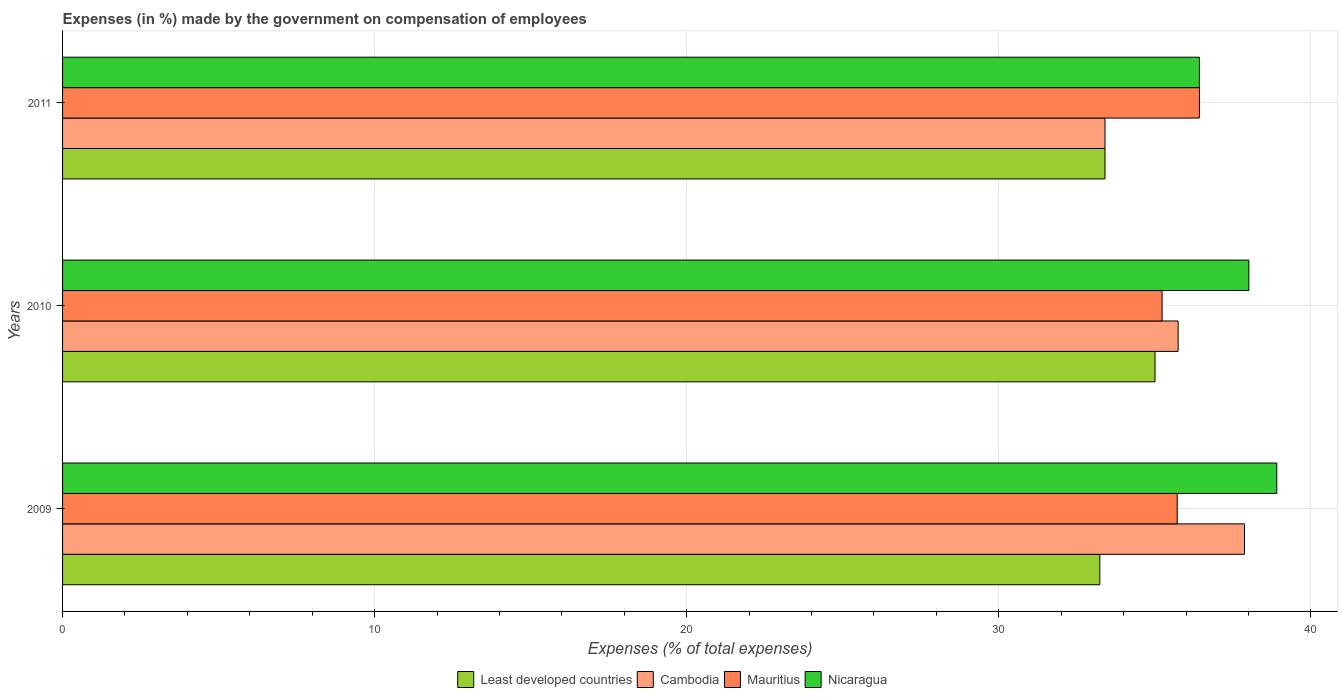How many groups of bars are there?
Your answer should be very brief. 3. How many bars are there on the 1st tick from the bottom?
Keep it short and to the point. 4. What is the label of the 3rd group of bars from the top?
Provide a short and direct response. 2009. What is the percentage of expenses made by the government on compensation of employees in Mauritius in 2011?
Provide a succinct answer. 36.43. Across all years, what is the maximum percentage of expenses made by the government on compensation of employees in Cambodia?
Keep it short and to the point. 37.88. Across all years, what is the minimum percentage of expenses made by the government on compensation of employees in Nicaragua?
Provide a succinct answer. 36.43. In which year was the percentage of expenses made by the government on compensation of employees in Least developed countries maximum?
Your answer should be compact. 2010. What is the total percentage of expenses made by the government on compensation of employees in Cambodia in the graph?
Offer a terse response. 107.03. What is the difference between the percentage of expenses made by the government on compensation of employees in Mauritius in 2009 and that in 2010?
Offer a very short reply. 0.49. What is the difference between the percentage of expenses made by the government on compensation of employees in Cambodia in 2010 and the percentage of expenses made by the government on compensation of employees in Least developed countries in 2009?
Your answer should be very brief. 2.51. What is the average percentage of expenses made by the government on compensation of employees in Nicaragua per year?
Offer a very short reply. 37.78. In the year 2009, what is the difference between the percentage of expenses made by the government on compensation of employees in Least developed countries and percentage of expenses made by the government on compensation of employees in Mauritius?
Provide a short and direct response. -2.48. In how many years, is the percentage of expenses made by the government on compensation of employees in Least developed countries greater than 34 %?
Give a very brief answer. 1. What is the ratio of the percentage of expenses made by the government on compensation of employees in Mauritius in 2009 to that in 2010?
Make the answer very short. 1.01. Is the difference between the percentage of expenses made by the government on compensation of employees in Least developed countries in 2009 and 2011 greater than the difference between the percentage of expenses made by the government on compensation of employees in Mauritius in 2009 and 2011?
Your response must be concise. Yes. What is the difference between the highest and the second highest percentage of expenses made by the government on compensation of employees in Mauritius?
Your answer should be compact. 0.71. What is the difference between the highest and the lowest percentage of expenses made by the government on compensation of employees in Nicaragua?
Make the answer very short. 2.48. Is the sum of the percentage of expenses made by the government on compensation of employees in Nicaragua in 2010 and 2011 greater than the maximum percentage of expenses made by the government on compensation of employees in Mauritius across all years?
Keep it short and to the point. Yes. What does the 4th bar from the top in 2010 represents?
Offer a very short reply. Least developed countries. What does the 3rd bar from the bottom in 2010 represents?
Offer a terse response. Mauritius. Is it the case that in every year, the sum of the percentage of expenses made by the government on compensation of employees in Cambodia and percentage of expenses made by the government on compensation of employees in Nicaragua is greater than the percentage of expenses made by the government on compensation of employees in Mauritius?
Offer a terse response. Yes. How many years are there in the graph?
Keep it short and to the point. 3. Are the values on the major ticks of X-axis written in scientific E-notation?
Keep it short and to the point. No. Does the graph contain any zero values?
Your answer should be very brief. No. Does the graph contain grids?
Keep it short and to the point. Yes. How are the legend labels stacked?
Provide a succinct answer. Horizontal. What is the title of the graph?
Give a very brief answer. Expenses (in %) made by the government on compensation of employees. Does "Finland" appear as one of the legend labels in the graph?
Ensure brevity in your answer.  No. What is the label or title of the X-axis?
Provide a succinct answer. Expenses (% of total expenses). What is the label or title of the Y-axis?
Offer a terse response. Years. What is the Expenses (% of total expenses) in Least developed countries in 2009?
Your answer should be compact. 33.24. What is the Expenses (% of total expenses) of Cambodia in 2009?
Your answer should be very brief. 37.88. What is the Expenses (% of total expenses) of Mauritius in 2009?
Offer a terse response. 35.72. What is the Expenses (% of total expenses) in Nicaragua in 2009?
Provide a short and direct response. 38.91. What is the Expenses (% of total expenses) in Least developed countries in 2010?
Your answer should be very brief. 35.01. What is the Expenses (% of total expenses) of Cambodia in 2010?
Your answer should be very brief. 35.75. What is the Expenses (% of total expenses) of Mauritius in 2010?
Provide a short and direct response. 35.23. What is the Expenses (% of total expenses) in Nicaragua in 2010?
Provide a short and direct response. 38.01. What is the Expenses (% of total expenses) of Least developed countries in 2011?
Give a very brief answer. 33.4. What is the Expenses (% of total expenses) in Cambodia in 2011?
Make the answer very short. 33.4. What is the Expenses (% of total expenses) of Mauritius in 2011?
Keep it short and to the point. 36.43. What is the Expenses (% of total expenses) of Nicaragua in 2011?
Provide a short and direct response. 36.43. Across all years, what is the maximum Expenses (% of total expenses) in Least developed countries?
Make the answer very short. 35.01. Across all years, what is the maximum Expenses (% of total expenses) of Cambodia?
Give a very brief answer. 37.88. Across all years, what is the maximum Expenses (% of total expenses) in Mauritius?
Your answer should be compact. 36.43. Across all years, what is the maximum Expenses (% of total expenses) of Nicaragua?
Keep it short and to the point. 38.91. Across all years, what is the minimum Expenses (% of total expenses) in Least developed countries?
Give a very brief answer. 33.24. Across all years, what is the minimum Expenses (% of total expenses) in Cambodia?
Keep it short and to the point. 33.4. Across all years, what is the minimum Expenses (% of total expenses) of Mauritius?
Provide a short and direct response. 35.23. Across all years, what is the minimum Expenses (% of total expenses) of Nicaragua?
Offer a very short reply. 36.43. What is the total Expenses (% of total expenses) in Least developed countries in the graph?
Provide a succinct answer. 101.65. What is the total Expenses (% of total expenses) of Cambodia in the graph?
Your answer should be very brief. 107.03. What is the total Expenses (% of total expenses) in Mauritius in the graph?
Your response must be concise. 107.38. What is the total Expenses (% of total expenses) in Nicaragua in the graph?
Provide a short and direct response. 113.35. What is the difference between the Expenses (% of total expenses) in Least developed countries in 2009 and that in 2010?
Provide a short and direct response. -1.77. What is the difference between the Expenses (% of total expenses) of Cambodia in 2009 and that in 2010?
Offer a terse response. 2.13. What is the difference between the Expenses (% of total expenses) of Mauritius in 2009 and that in 2010?
Your answer should be very brief. 0.49. What is the difference between the Expenses (% of total expenses) of Nicaragua in 2009 and that in 2010?
Make the answer very short. 0.89. What is the difference between the Expenses (% of total expenses) in Least developed countries in 2009 and that in 2011?
Offer a very short reply. -0.17. What is the difference between the Expenses (% of total expenses) of Cambodia in 2009 and that in 2011?
Your answer should be very brief. 4.47. What is the difference between the Expenses (% of total expenses) in Mauritius in 2009 and that in 2011?
Offer a very short reply. -0.71. What is the difference between the Expenses (% of total expenses) in Nicaragua in 2009 and that in 2011?
Provide a short and direct response. 2.48. What is the difference between the Expenses (% of total expenses) of Least developed countries in 2010 and that in 2011?
Your answer should be compact. 1.6. What is the difference between the Expenses (% of total expenses) of Cambodia in 2010 and that in 2011?
Offer a very short reply. 2.34. What is the difference between the Expenses (% of total expenses) in Mauritius in 2010 and that in 2011?
Make the answer very short. -1.2. What is the difference between the Expenses (% of total expenses) of Nicaragua in 2010 and that in 2011?
Your answer should be compact. 1.58. What is the difference between the Expenses (% of total expenses) of Least developed countries in 2009 and the Expenses (% of total expenses) of Cambodia in 2010?
Your response must be concise. -2.51. What is the difference between the Expenses (% of total expenses) of Least developed countries in 2009 and the Expenses (% of total expenses) of Mauritius in 2010?
Offer a terse response. -1.99. What is the difference between the Expenses (% of total expenses) in Least developed countries in 2009 and the Expenses (% of total expenses) in Nicaragua in 2010?
Provide a succinct answer. -4.78. What is the difference between the Expenses (% of total expenses) of Cambodia in 2009 and the Expenses (% of total expenses) of Mauritius in 2010?
Provide a succinct answer. 2.64. What is the difference between the Expenses (% of total expenses) of Cambodia in 2009 and the Expenses (% of total expenses) of Nicaragua in 2010?
Your answer should be very brief. -0.14. What is the difference between the Expenses (% of total expenses) in Mauritius in 2009 and the Expenses (% of total expenses) in Nicaragua in 2010?
Ensure brevity in your answer.  -2.3. What is the difference between the Expenses (% of total expenses) of Least developed countries in 2009 and the Expenses (% of total expenses) of Cambodia in 2011?
Offer a terse response. -0.17. What is the difference between the Expenses (% of total expenses) of Least developed countries in 2009 and the Expenses (% of total expenses) of Mauritius in 2011?
Give a very brief answer. -3.19. What is the difference between the Expenses (% of total expenses) of Least developed countries in 2009 and the Expenses (% of total expenses) of Nicaragua in 2011?
Give a very brief answer. -3.19. What is the difference between the Expenses (% of total expenses) of Cambodia in 2009 and the Expenses (% of total expenses) of Mauritius in 2011?
Offer a very short reply. 1.45. What is the difference between the Expenses (% of total expenses) of Cambodia in 2009 and the Expenses (% of total expenses) of Nicaragua in 2011?
Provide a succinct answer. 1.45. What is the difference between the Expenses (% of total expenses) of Mauritius in 2009 and the Expenses (% of total expenses) of Nicaragua in 2011?
Keep it short and to the point. -0.71. What is the difference between the Expenses (% of total expenses) in Least developed countries in 2010 and the Expenses (% of total expenses) in Cambodia in 2011?
Your answer should be compact. 1.6. What is the difference between the Expenses (% of total expenses) of Least developed countries in 2010 and the Expenses (% of total expenses) of Mauritius in 2011?
Provide a succinct answer. -1.42. What is the difference between the Expenses (% of total expenses) in Least developed countries in 2010 and the Expenses (% of total expenses) in Nicaragua in 2011?
Make the answer very short. -1.42. What is the difference between the Expenses (% of total expenses) of Cambodia in 2010 and the Expenses (% of total expenses) of Mauritius in 2011?
Keep it short and to the point. -0.68. What is the difference between the Expenses (% of total expenses) in Cambodia in 2010 and the Expenses (% of total expenses) in Nicaragua in 2011?
Offer a terse response. -0.68. What is the difference between the Expenses (% of total expenses) of Mauritius in 2010 and the Expenses (% of total expenses) of Nicaragua in 2011?
Provide a short and direct response. -1.2. What is the average Expenses (% of total expenses) of Least developed countries per year?
Make the answer very short. 33.88. What is the average Expenses (% of total expenses) in Cambodia per year?
Provide a succinct answer. 35.68. What is the average Expenses (% of total expenses) in Mauritius per year?
Keep it short and to the point. 35.79. What is the average Expenses (% of total expenses) in Nicaragua per year?
Your answer should be compact. 37.78. In the year 2009, what is the difference between the Expenses (% of total expenses) in Least developed countries and Expenses (% of total expenses) in Cambodia?
Your answer should be compact. -4.64. In the year 2009, what is the difference between the Expenses (% of total expenses) in Least developed countries and Expenses (% of total expenses) in Mauritius?
Keep it short and to the point. -2.48. In the year 2009, what is the difference between the Expenses (% of total expenses) of Least developed countries and Expenses (% of total expenses) of Nicaragua?
Provide a succinct answer. -5.67. In the year 2009, what is the difference between the Expenses (% of total expenses) of Cambodia and Expenses (% of total expenses) of Mauritius?
Your answer should be compact. 2.16. In the year 2009, what is the difference between the Expenses (% of total expenses) of Cambodia and Expenses (% of total expenses) of Nicaragua?
Your answer should be compact. -1.03. In the year 2009, what is the difference between the Expenses (% of total expenses) in Mauritius and Expenses (% of total expenses) in Nicaragua?
Keep it short and to the point. -3.19. In the year 2010, what is the difference between the Expenses (% of total expenses) in Least developed countries and Expenses (% of total expenses) in Cambodia?
Ensure brevity in your answer.  -0.74. In the year 2010, what is the difference between the Expenses (% of total expenses) in Least developed countries and Expenses (% of total expenses) in Mauritius?
Offer a very short reply. -0.23. In the year 2010, what is the difference between the Expenses (% of total expenses) in Least developed countries and Expenses (% of total expenses) in Nicaragua?
Your response must be concise. -3.01. In the year 2010, what is the difference between the Expenses (% of total expenses) of Cambodia and Expenses (% of total expenses) of Mauritius?
Provide a short and direct response. 0.51. In the year 2010, what is the difference between the Expenses (% of total expenses) in Cambodia and Expenses (% of total expenses) in Nicaragua?
Keep it short and to the point. -2.27. In the year 2010, what is the difference between the Expenses (% of total expenses) in Mauritius and Expenses (% of total expenses) in Nicaragua?
Your response must be concise. -2.78. In the year 2011, what is the difference between the Expenses (% of total expenses) in Least developed countries and Expenses (% of total expenses) in Cambodia?
Provide a short and direct response. 0. In the year 2011, what is the difference between the Expenses (% of total expenses) in Least developed countries and Expenses (% of total expenses) in Mauritius?
Make the answer very short. -3.03. In the year 2011, what is the difference between the Expenses (% of total expenses) in Least developed countries and Expenses (% of total expenses) in Nicaragua?
Offer a terse response. -3.03. In the year 2011, what is the difference between the Expenses (% of total expenses) of Cambodia and Expenses (% of total expenses) of Mauritius?
Offer a very short reply. -3.03. In the year 2011, what is the difference between the Expenses (% of total expenses) in Cambodia and Expenses (% of total expenses) in Nicaragua?
Your answer should be very brief. -3.03. In the year 2011, what is the difference between the Expenses (% of total expenses) in Mauritius and Expenses (% of total expenses) in Nicaragua?
Your answer should be compact. -0. What is the ratio of the Expenses (% of total expenses) in Least developed countries in 2009 to that in 2010?
Provide a succinct answer. 0.95. What is the ratio of the Expenses (% of total expenses) in Cambodia in 2009 to that in 2010?
Provide a succinct answer. 1.06. What is the ratio of the Expenses (% of total expenses) in Mauritius in 2009 to that in 2010?
Make the answer very short. 1.01. What is the ratio of the Expenses (% of total expenses) of Nicaragua in 2009 to that in 2010?
Offer a terse response. 1.02. What is the ratio of the Expenses (% of total expenses) of Least developed countries in 2009 to that in 2011?
Provide a short and direct response. 0.99. What is the ratio of the Expenses (% of total expenses) of Cambodia in 2009 to that in 2011?
Provide a short and direct response. 1.13. What is the ratio of the Expenses (% of total expenses) in Mauritius in 2009 to that in 2011?
Provide a short and direct response. 0.98. What is the ratio of the Expenses (% of total expenses) of Nicaragua in 2009 to that in 2011?
Your response must be concise. 1.07. What is the ratio of the Expenses (% of total expenses) of Least developed countries in 2010 to that in 2011?
Your response must be concise. 1.05. What is the ratio of the Expenses (% of total expenses) in Cambodia in 2010 to that in 2011?
Provide a succinct answer. 1.07. What is the ratio of the Expenses (% of total expenses) of Mauritius in 2010 to that in 2011?
Provide a short and direct response. 0.97. What is the ratio of the Expenses (% of total expenses) of Nicaragua in 2010 to that in 2011?
Ensure brevity in your answer.  1.04. What is the difference between the highest and the second highest Expenses (% of total expenses) of Least developed countries?
Provide a short and direct response. 1.6. What is the difference between the highest and the second highest Expenses (% of total expenses) of Cambodia?
Your answer should be compact. 2.13. What is the difference between the highest and the second highest Expenses (% of total expenses) of Mauritius?
Offer a terse response. 0.71. What is the difference between the highest and the second highest Expenses (% of total expenses) of Nicaragua?
Offer a terse response. 0.89. What is the difference between the highest and the lowest Expenses (% of total expenses) in Least developed countries?
Offer a terse response. 1.77. What is the difference between the highest and the lowest Expenses (% of total expenses) in Cambodia?
Offer a very short reply. 4.47. What is the difference between the highest and the lowest Expenses (% of total expenses) of Mauritius?
Give a very brief answer. 1.2. What is the difference between the highest and the lowest Expenses (% of total expenses) of Nicaragua?
Keep it short and to the point. 2.48. 